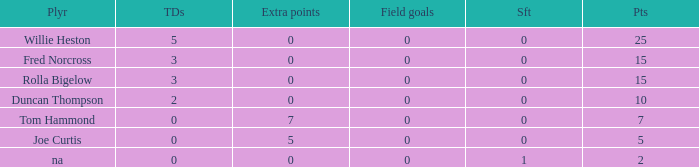Identify the smallest points figure having less than 2 touchdowns, 7 extra points, and a field goals count below 0. None. 